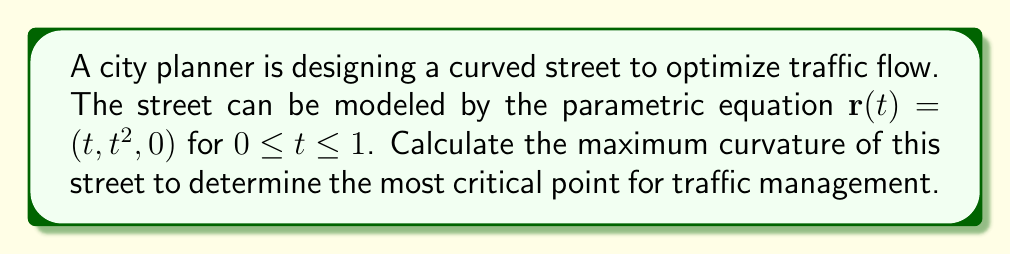Could you help me with this problem? To find the maximum curvature of the street, we'll follow these steps:

1) The curvature $\kappa$ is given by the formula:

   $$\kappa = \frac{|\mathbf{r}'(t) \times \mathbf{r}''(t)|}{|\mathbf{r}'(t)|^3}$$

2) Calculate $\mathbf{r}'(t)$:
   $$\mathbf{r}'(t) = (1, 2t, 0)$$

3) Calculate $\mathbf{r}''(t)$:
   $$\mathbf{r}''(t) = (0, 2, 0)$$

4) Calculate $\mathbf{r}'(t) \times \mathbf{r}''(t)$:
   $$\mathbf{r}'(t) \times \mathbf{r}''(t) = (0, 0, 2)$$

5) Calculate $|\mathbf{r}'(t) \times \mathbf{r}''(t)|$:
   $$|\mathbf{r}'(t) \times \mathbf{r}''(t)| = 2$$

6) Calculate $|\mathbf{r}'(t)|$:
   $$|\mathbf{r}'(t)| = \sqrt{1^2 + (2t)^2} = \sqrt{1 + 4t^2}$$

7) Now, we can express the curvature as a function of $t$:
   $$\kappa(t) = \frac{2}{(1 + 4t^2)^{3/2}}$$

8) To find the maximum curvature, we need to find the minimum of $(1 + 4t^2)^{3/2}$. The minimum occurs when $t = 0$.

9) Therefore, the maximum curvature occurs at $t = 0$:
   $$\kappa_{max} = \kappa(0) = \frac{2}{1^{3/2}} = 2$$
Answer: $2$ 